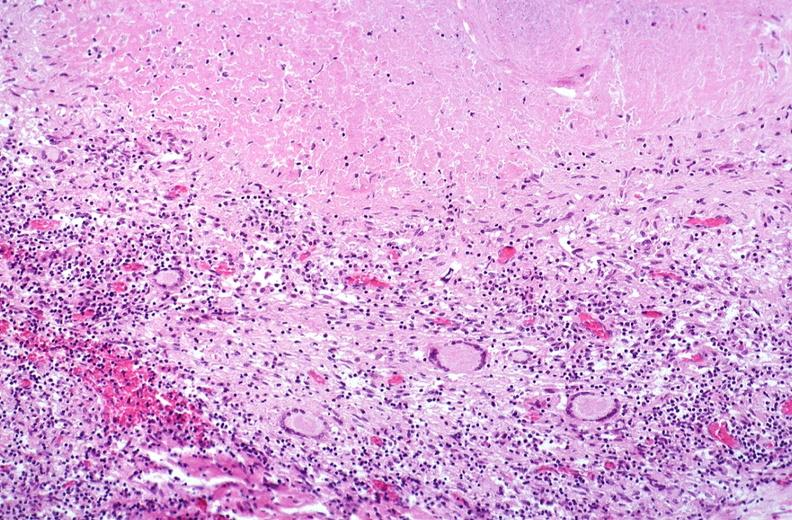what does this image show?
Answer the question using a single word or phrase. Lung 